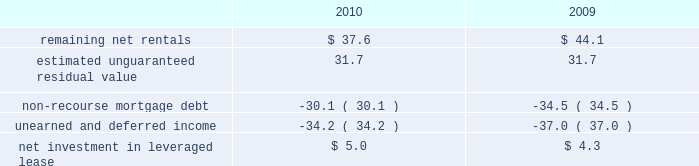Kimco realty corporation and subsidiaries notes to consolidated financial statements , continued investment in retail store leases 2014 the company has interests in various retail store leases relating to the anchor store premises in neighborhood and community shopping centers .
These premises have been sublet to retailers who lease the stores pursuant to net lease agreements .
Income from the investment in these retail store leases during the years ended december 31 , 2010 , 2009 and 2008 , was approximately $ 1.6 million , $ 0.8 million and $ 2.7 million , respectively .
These amounts represent sublease revenues during the years ended december 31 , 2010 , 2009 and 2008 , of approximately $ 5.9 million , $ 5.2 million and $ 7.1 million , respectively , less related expenses of $ 4.3 million , $ 4.4 million and $ 4.4 million , respectively .
The company 2019s future minimum revenues under the terms of all non-cancelable tenant subleases and future minimum obligations through the remaining terms of its retail store leases , assuming no new or renegotiated leases are executed for such premises , for future years are as follows ( in millions ) : 2011 , $ 5.2 and $ 3.4 ; 2012 , $ 4.1 and $ 2.6 ; 2013 , $ 3.8 and $ 2.3 ; 2014 , $ 2.9 and $ 1.7 ; 2015 , $ 2.1 and $ 1.3 , and thereafter , $ 2.8 and $ 1.6 , respectively .
Leveraged lease 2014 during june 2002 , the company acquired a 90% ( 90 % ) equity participation interest in an existing leveraged lease of 30 properties .
The properties are leased under a long-term bond-type net lease whose primary term expires in 2016 , with the lessee having certain renewal option rights .
The company 2019s cash equity investment was approximately $ 4.0 million .
This equity investment is reported as a net investment in leveraged lease in accordance with the fasb 2019s lease guidance .
As of december 31 , 2010 , 18 of these properties were sold , whereby the proceeds from the sales were used to pay down the mortgage debt by approximately $ 31.2 million and the remaining 12 properties were encumbered by third-party non-recourse debt of approximately $ 33.4 million that is scheduled to fully amortize during the primary term of the lease from a portion of the periodic net rents receivable under the net lease .
As an equity participant in the leveraged lease , the company has no recourse obligation for principal or interest payments on the debt , which is collateralized by a first mortgage lien on the properties and collateral assignment of the lease .
Accordingly , this obligation has been offset against the related net rental receivable under the lease .
At december 31 , 2010 and 2009 , the company 2019s net investment in the leveraged lease consisted of the following ( in millions ) : .
10 .
Variable interest entities : consolidated operating properties 2014 included within the company 2019s consolidated operating properties at december 31 , 2010 are four consolidated entities that are vies and for which the company is the primary beneficiary .
All of these entities have been established to own and operate real estate property .
The company 2019s involvement with these entities is through its majority ownership of the properties .
These entities were deemed vies primarily based on the fact that the voting rights of the equity investors are not proportional to their obligation to absorb expected losses or receive the expected residual returns of the entity and substantially all of the entity 2019s activities are conducted on behalf of the investor which has disproportionately fewer voting rights .
The company determined that it was the primary beneficiary of these vies as a result of its controlling financial interest .
During 2010 , the company sold two consolidated vie 2019s which the company was the primary beneficiary. .
What is the growth rate in expenses incurred due to subleasing in 2010? 
Computations: ((4.3 - 4.4) / 4.4)
Answer: -0.02273. 